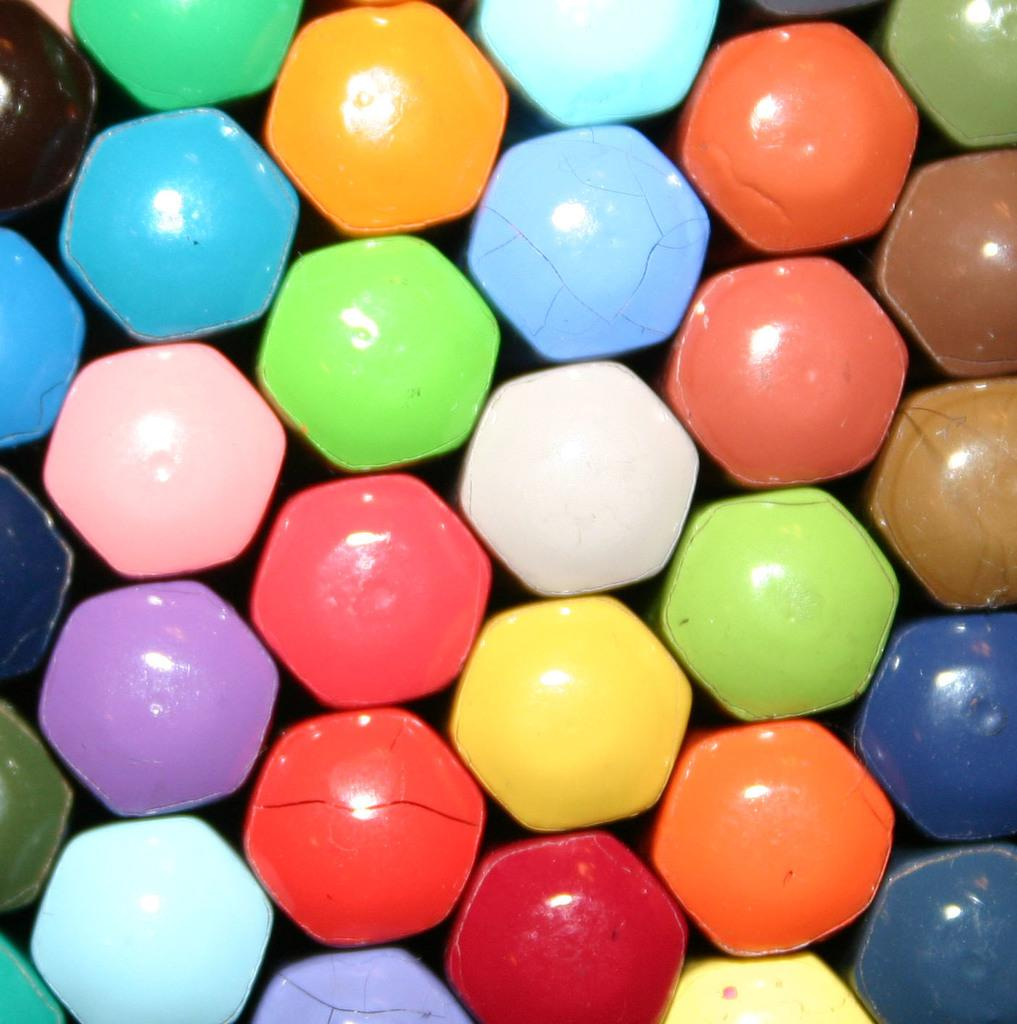What type of stationery items are visible in the image? There are different color pencils in the image. What type of pump can be seen in the image? There is no pump present in the image; it features different color pencils. What type of earth is visible in the image? There is no earth present in the image; it features different color pencils. 